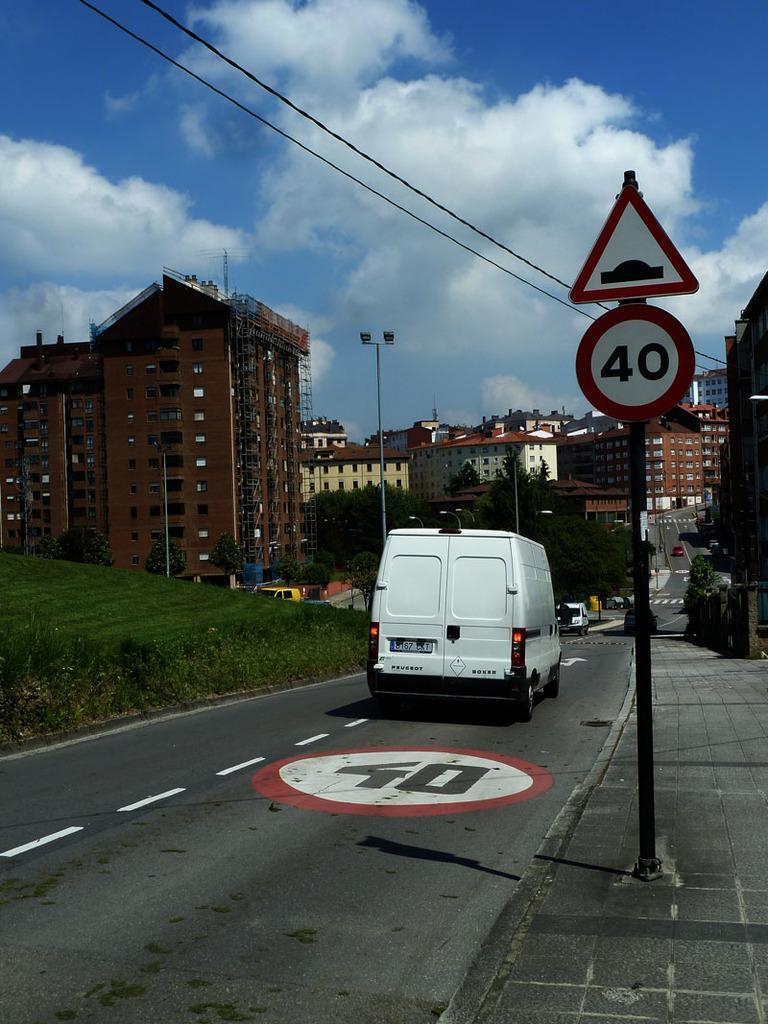In one or two sentences, can you explain what this image depicts? In this image there are few vehicles moving on the road and there is a sign board. In the background there are buildings, trees, poles and the sky. 